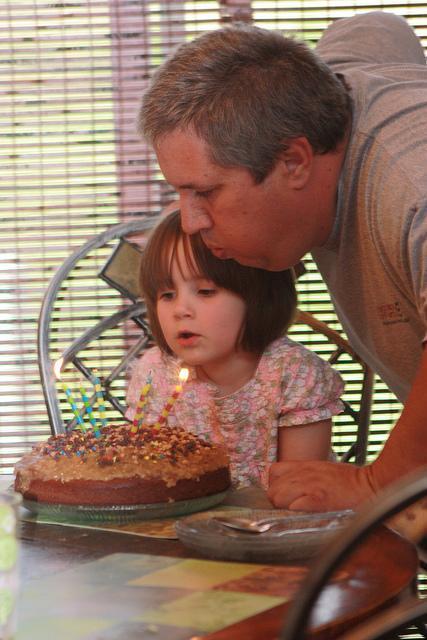How many chairs can be seen?
Give a very brief answer. 2. How many dining tables are there?
Give a very brief answer. 1. How many people can you see?
Give a very brief answer. 2. 